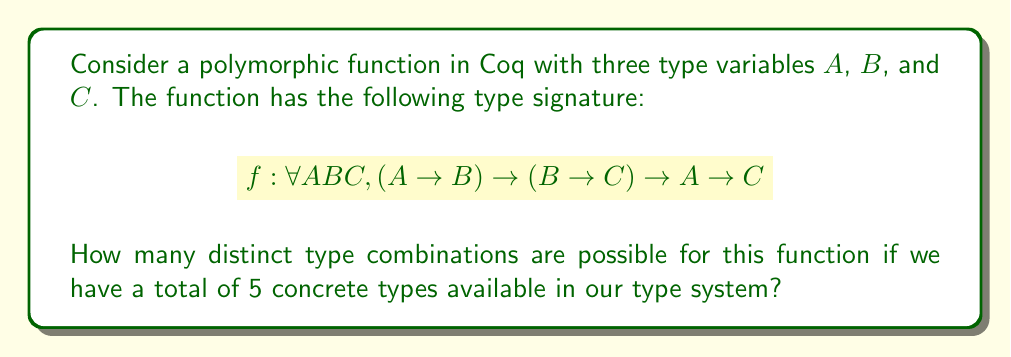Teach me how to tackle this problem. Let's approach this step-by-step:

1) We have three type variables: $A$, $B$, and $C$.

2) For each of these type variables, we can choose any of the 5 concrete types available.

3) The choices for each type variable are independent of each other.

4) This scenario is analogous to choosing with replacement from a set of 5 elements, three times.

5) In combinatorics, this is represented as $5^3$, because:
   - We have 5 choices for $A$
   - For each choice of $A$, we have 5 choices for $B$
   - For each choice of $A$ and $B$, we have 5 choices for $C$

6) Therefore, the total number of possible type combinations is:

   $$5 \times 5 \times 5 = 5^3 = 125$$

This approach is similar to traversing a dependency tree in software development, where each node (type variable) has 5 possible child nodes (concrete types).
Answer: $125$ 